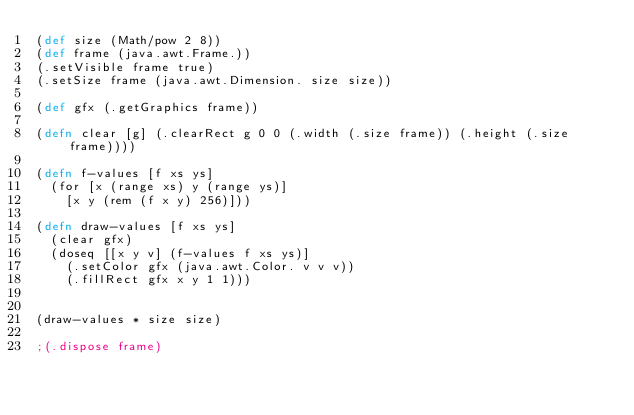Convert code to text. <code><loc_0><loc_0><loc_500><loc_500><_Clojure_>(def size (Math/pow 2 8))
(def frame (java.awt.Frame.))
(.setVisible frame true)
(.setSize frame (java.awt.Dimension. size size))

(def gfx (.getGraphics frame))

(defn clear [g] (.clearRect g 0 0 (.width (.size frame)) (.height (.size frame))))

(defn f-values [f xs ys]
  (for [x (range xs) y (range ys)]
    [x y (rem (f x y) 256)]))

(defn draw-values [f xs ys]
  (clear gfx)
  (doseq [[x y v] (f-values f xs ys)]
    (.setColor gfx (java.awt.Color. v v v))
    (.fillRect gfx x y 1 1)))


(draw-values * size size)

;(.dispose frame)</code> 